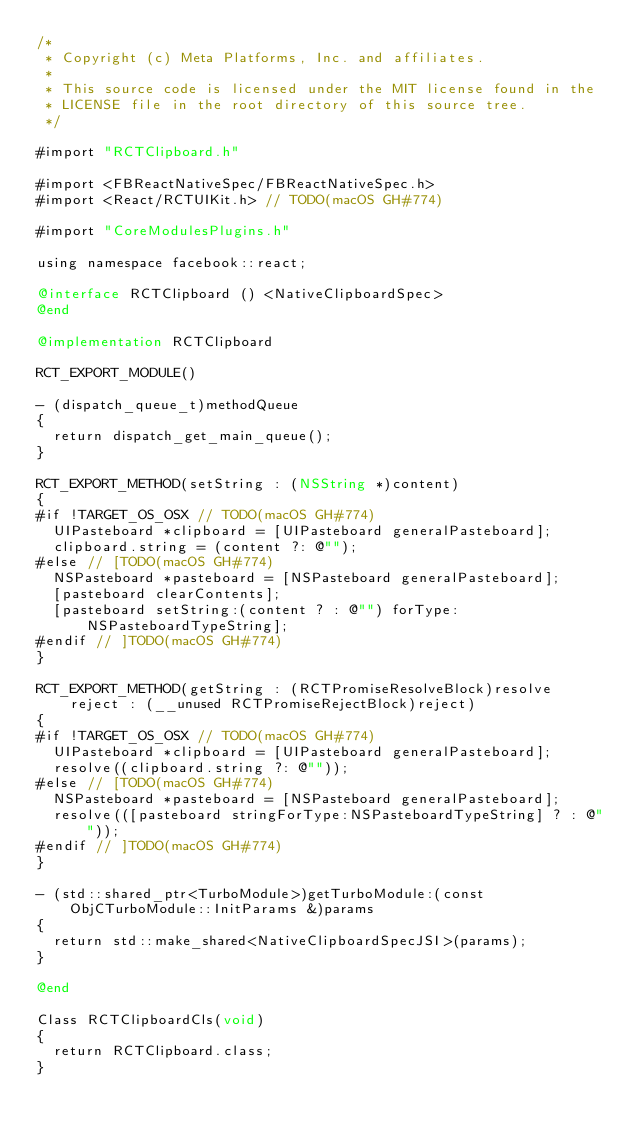<code> <loc_0><loc_0><loc_500><loc_500><_ObjectiveC_>/*
 * Copyright (c) Meta Platforms, Inc. and affiliates.
 *
 * This source code is licensed under the MIT license found in the
 * LICENSE file in the root directory of this source tree.
 */

#import "RCTClipboard.h"

#import <FBReactNativeSpec/FBReactNativeSpec.h>
#import <React/RCTUIKit.h> // TODO(macOS GH#774)

#import "CoreModulesPlugins.h"

using namespace facebook::react;

@interface RCTClipboard () <NativeClipboardSpec>
@end

@implementation RCTClipboard

RCT_EXPORT_MODULE()

- (dispatch_queue_t)methodQueue
{
  return dispatch_get_main_queue();
}

RCT_EXPORT_METHOD(setString : (NSString *)content)
{
#if !TARGET_OS_OSX // TODO(macOS GH#774)
  UIPasteboard *clipboard = [UIPasteboard generalPasteboard];
  clipboard.string = (content ?: @"");
#else // [TODO(macOS GH#774)
  NSPasteboard *pasteboard = [NSPasteboard generalPasteboard];
  [pasteboard clearContents];
  [pasteboard setString:(content ? : @"") forType:NSPasteboardTypeString];
#endif // ]TODO(macOS GH#774)
}

RCT_EXPORT_METHOD(getString : (RCTPromiseResolveBlock)resolve reject : (__unused RCTPromiseRejectBlock)reject)
{
#if !TARGET_OS_OSX // TODO(macOS GH#774)
  UIPasteboard *clipboard = [UIPasteboard generalPasteboard];
  resolve((clipboard.string ?: @""));
#else // [TODO(macOS GH#774)
  NSPasteboard *pasteboard = [NSPasteboard generalPasteboard];
  resolve(([pasteboard stringForType:NSPasteboardTypeString] ? : @""));
#endif // ]TODO(macOS GH#774)
}

- (std::shared_ptr<TurboModule>)getTurboModule:(const ObjCTurboModule::InitParams &)params
{
  return std::make_shared<NativeClipboardSpecJSI>(params);
}

@end

Class RCTClipboardCls(void)
{
  return RCTClipboard.class;
}
</code> 